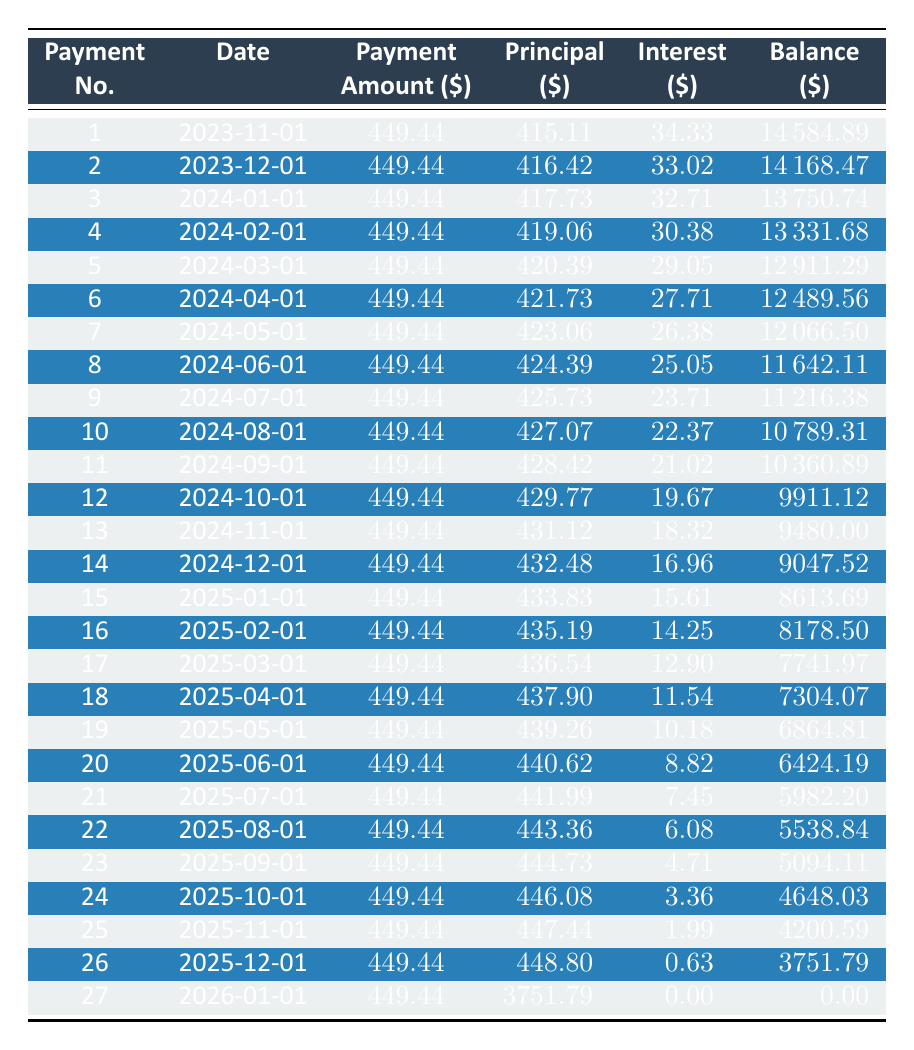What is the amount of the first payment made by John Smith? The first payment date is November 1, 2023, and the corresponding payment amount is listed as 449.44.
Answer: 449.44 How much principal was paid off in the fifth payment? From the table, the principal value for the fifth payment on March 1, 2024, is shown as 420.39.
Answer: 420.39 What is the remaining balance after the 10th payment? The remaining balance is listed in the table under the 10th payment on August 1, 2024, which is shown as 10789.31.
Answer: 10789.31 What was the total amount of interest paid by the end of the loan? To find the total interest, we sum all the interest payments from each row. The total interest amounts to (34.33 + 33.02 + 32.71 + 30.38 + 29.05 + 27.71 + 26.38 + 25.05 + 23.71 + 22.37 + 21.02 + 19.67 + 18.32 + 16.96 + 15.61 + 14.25 + 12.90 + 11.54 + 10.18 + 8.82 + 7.45 + 6.08 + 4.71 + 3.36 + 1.99 + 0.63 + 0) = 576.42.
Answer: 576.42 Is the remaining balance after the 20th payment less than 6000? The remaining balance after the 20th payment on June 1, 2025, is reported as 6424.19, which is indeed greater than 6000. Therefore, the statement is false.
Answer: No What is the average payment amount over the duration of the loan? The number of payments is 27, and each payment is 449.44. The total payment amount is 449.44 * 27 = 12135.88. The average payment is 12135.88 / 27 = 449.44.
Answer: 449.44 How many payments were made before the remaining balance fell below 5000? By reviewing the table, the remaining balance falls below 5000 after the 23rd payment on September 1, 2025. Thus, payments made before this point total 23.
Answer: 23 What is the difference between the principal paid in the first payment and the principal paid in the last payment? The principal for the first payment is 415.11 and for the last payment is 3751.79. The difference is 3751.79 - 415.11 = 3336.68.
Answer: 3336.68 Does the interest payment decrease as the loan progresses? Observing the interest amounts, it consistently decreases from the first payment (34.33) to the last payment (0). Therefore the statement is true.
Answer: Yes 